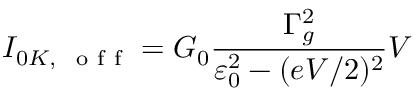Convert formula to latex. <formula><loc_0><loc_0><loc_500><loc_500>I _ { 0 K , o f f } = G _ { 0 } \frac { \Gamma _ { g } ^ { 2 } } { \varepsilon _ { 0 } ^ { 2 } - ( e V / 2 ) ^ { 2 } } V</formula> 